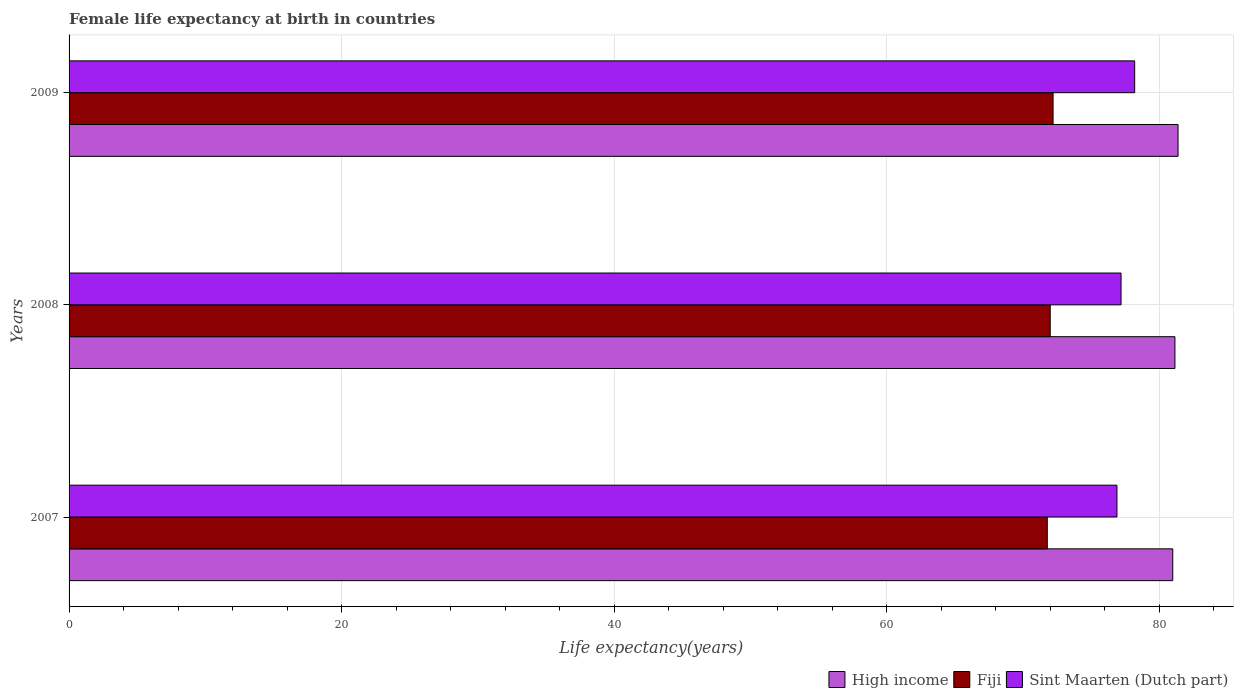Are the number of bars per tick equal to the number of legend labels?
Your response must be concise. Yes. In how many cases, is the number of bars for a given year not equal to the number of legend labels?
Your answer should be compact. 0. What is the female life expectancy at birth in Sint Maarten (Dutch part) in 2009?
Give a very brief answer. 78.2. Across all years, what is the maximum female life expectancy at birth in High income?
Your answer should be very brief. 81.38. Across all years, what is the minimum female life expectancy at birth in Sint Maarten (Dutch part)?
Your answer should be very brief. 76.9. In which year was the female life expectancy at birth in Fiji maximum?
Provide a short and direct response. 2009. What is the total female life expectancy at birth in Sint Maarten (Dutch part) in the graph?
Give a very brief answer. 232.3. What is the difference between the female life expectancy at birth in High income in 2008 and that in 2009?
Make the answer very short. -0.23. What is the difference between the female life expectancy at birth in Fiji in 2008 and the female life expectancy at birth in High income in 2007?
Ensure brevity in your answer.  -8.99. What is the average female life expectancy at birth in Sint Maarten (Dutch part) per year?
Your answer should be compact. 77.43. In the year 2008, what is the difference between the female life expectancy at birth in Sint Maarten (Dutch part) and female life expectancy at birth in High income?
Keep it short and to the point. -3.95. In how many years, is the female life expectancy at birth in Fiji greater than 52 years?
Keep it short and to the point. 3. What is the ratio of the female life expectancy at birth in High income in 2007 to that in 2009?
Ensure brevity in your answer.  1. What is the difference between the highest and the second highest female life expectancy at birth in High income?
Your response must be concise. 0.23. What is the difference between the highest and the lowest female life expectancy at birth in Fiji?
Give a very brief answer. 0.43. Is the sum of the female life expectancy at birth in High income in 2008 and 2009 greater than the maximum female life expectancy at birth in Sint Maarten (Dutch part) across all years?
Make the answer very short. Yes. What does the 2nd bar from the top in 2008 represents?
Your answer should be compact. Fiji. What does the 2nd bar from the bottom in 2009 represents?
Offer a very short reply. Fiji. How many bars are there?
Your answer should be compact. 9. Are all the bars in the graph horizontal?
Offer a very short reply. Yes. What is the difference between two consecutive major ticks on the X-axis?
Your answer should be very brief. 20. Does the graph contain any zero values?
Make the answer very short. No. Where does the legend appear in the graph?
Your answer should be very brief. Bottom right. How are the legend labels stacked?
Offer a terse response. Horizontal. What is the title of the graph?
Your response must be concise. Female life expectancy at birth in countries. Does "Croatia" appear as one of the legend labels in the graph?
Offer a terse response. No. What is the label or title of the X-axis?
Give a very brief answer. Life expectancy(years). What is the Life expectancy(years) in High income in 2007?
Make the answer very short. 81. What is the Life expectancy(years) of Fiji in 2007?
Make the answer very short. 71.79. What is the Life expectancy(years) in Sint Maarten (Dutch part) in 2007?
Give a very brief answer. 76.9. What is the Life expectancy(years) of High income in 2008?
Provide a short and direct response. 81.15. What is the Life expectancy(years) in Fiji in 2008?
Your answer should be compact. 72. What is the Life expectancy(years) of Sint Maarten (Dutch part) in 2008?
Offer a terse response. 77.2. What is the Life expectancy(years) of High income in 2009?
Offer a terse response. 81.38. What is the Life expectancy(years) in Fiji in 2009?
Give a very brief answer. 72.21. What is the Life expectancy(years) in Sint Maarten (Dutch part) in 2009?
Your answer should be compact. 78.2. Across all years, what is the maximum Life expectancy(years) in High income?
Ensure brevity in your answer.  81.38. Across all years, what is the maximum Life expectancy(years) in Fiji?
Offer a very short reply. 72.21. Across all years, what is the maximum Life expectancy(years) of Sint Maarten (Dutch part)?
Provide a short and direct response. 78.2. Across all years, what is the minimum Life expectancy(years) in High income?
Provide a short and direct response. 81. Across all years, what is the minimum Life expectancy(years) in Fiji?
Offer a very short reply. 71.79. Across all years, what is the minimum Life expectancy(years) in Sint Maarten (Dutch part)?
Provide a succinct answer. 76.9. What is the total Life expectancy(years) in High income in the graph?
Keep it short and to the point. 243.53. What is the total Life expectancy(years) of Fiji in the graph?
Ensure brevity in your answer.  216. What is the total Life expectancy(years) of Sint Maarten (Dutch part) in the graph?
Your answer should be very brief. 232.3. What is the difference between the Life expectancy(years) in High income in 2007 and that in 2008?
Provide a short and direct response. -0.16. What is the difference between the Life expectancy(years) in Fiji in 2007 and that in 2008?
Keep it short and to the point. -0.22. What is the difference between the Life expectancy(years) in High income in 2007 and that in 2009?
Your answer should be compact. -0.39. What is the difference between the Life expectancy(years) in Fiji in 2007 and that in 2009?
Make the answer very short. -0.42. What is the difference between the Life expectancy(years) in High income in 2008 and that in 2009?
Your answer should be compact. -0.23. What is the difference between the Life expectancy(years) of Fiji in 2008 and that in 2009?
Provide a succinct answer. -0.21. What is the difference between the Life expectancy(years) in High income in 2007 and the Life expectancy(years) in Fiji in 2008?
Make the answer very short. 8.99. What is the difference between the Life expectancy(years) of High income in 2007 and the Life expectancy(years) of Sint Maarten (Dutch part) in 2008?
Make the answer very short. 3.8. What is the difference between the Life expectancy(years) in Fiji in 2007 and the Life expectancy(years) in Sint Maarten (Dutch part) in 2008?
Offer a very short reply. -5.41. What is the difference between the Life expectancy(years) in High income in 2007 and the Life expectancy(years) in Fiji in 2009?
Ensure brevity in your answer.  8.78. What is the difference between the Life expectancy(years) in High income in 2007 and the Life expectancy(years) in Sint Maarten (Dutch part) in 2009?
Make the answer very short. 2.8. What is the difference between the Life expectancy(years) of Fiji in 2007 and the Life expectancy(years) of Sint Maarten (Dutch part) in 2009?
Your response must be concise. -6.41. What is the difference between the Life expectancy(years) in High income in 2008 and the Life expectancy(years) in Fiji in 2009?
Provide a succinct answer. 8.94. What is the difference between the Life expectancy(years) in High income in 2008 and the Life expectancy(years) in Sint Maarten (Dutch part) in 2009?
Make the answer very short. 2.95. What is the difference between the Life expectancy(years) of Fiji in 2008 and the Life expectancy(years) of Sint Maarten (Dutch part) in 2009?
Give a very brief answer. -6.2. What is the average Life expectancy(years) in High income per year?
Provide a short and direct response. 81.18. What is the average Life expectancy(years) in Fiji per year?
Ensure brevity in your answer.  72. What is the average Life expectancy(years) in Sint Maarten (Dutch part) per year?
Your answer should be very brief. 77.43. In the year 2007, what is the difference between the Life expectancy(years) in High income and Life expectancy(years) in Fiji?
Your response must be concise. 9.21. In the year 2007, what is the difference between the Life expectancy(years) in High income and Life expectancy(years) in Sint Maarten (Dutch part)?
Your response must be concise. 4.1. In the year 2007, what is the difference between the Life expectancy(years) in Fiji and Life expectancy(years) in Sint Maarten (Dutch part)?
Your answer should be compact. -5.11. In the year 2008, what is the difference between the Life expectancy(years) of High income and Life expectancy(years) of Fiji?
Your answer should be very brief. 9.15. In the year 2008, what is the difference between the Life expectancy(years) in High income and Life expectancy(years) in Sint Maarten (Dutch part)?
Offer a terse response. 3.95. In the year 2008, what is the difference between the Life expectancy(years) in Fiji and Life expectancy(years) in Sint Maarten (Dutch part)?
Your response must be concise. -5.2. In the year 2009, what is the difference between the Life expectancy(years) in High income and Life expectancy(years) in Fiji?
Make the answer very short. 9.17. In the year 2009, what is the difference between the Life expectancy(years) of High income and Life expectancy(years) of Sint Maarten (Dutch part)?
Offer a very short reply. 3.18. In the year 2009, what is the difference between the Life expectancy(years) in Fiji and Life expectancy(years) in Sint Maarten (Dutch part)?
Your answer should be very brief. -5.99. What is the ratio of the Life expectancy(years) of Sint Maarten (Dutch part) in 2007 to that in 2008?
Provide a succinct answer. 1. What is the ratio of the Life expectancy(years) of Fiji in 2007 to that in 2009?
Your response must be concise. 0.99. What is the ratio of the Life expectancy(years) of Sint Maarten (Dutch part) in 2007 to that in 2009?
Make the answer very short. 0.98. What is the ratio of the Life expectancy(years) in Fiji in 2008 to that in 2009?
Ensure brevity in your answer.  1. What is the ratio of the Life expectancy(years) of Sint Maarten (Dutch part) in 2008 to that in 2009?
Keep it short and to the point. 0.99. What is the difference between the highest and the second highest Life expectancy(years) of High income?
Provide a succinct answer. 0.23. What is the difference between the highest and the second highest Life expectancy(years) of Fiji?
Make the answer very short. 0.21. What is the difference between the highest and the lowest Life expectancy(years) in High income?
Your response must be concise. 0.39. What is the difference between the highest and the lowest Life expectancy(years) in Fiji?
Offer a terse response. 0.42. What is the difference between the highest and the lowest Life expectancy(years) in Sint Maarten (Dutch part)?
Offer a terse response. 1.3. 